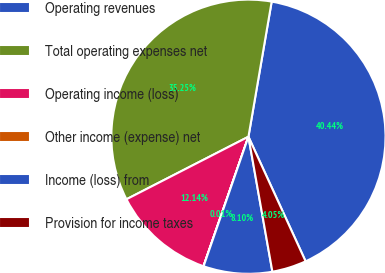<chart> <loc_0><loc_0><loc_500><loc_500><pie_chart><fcel>Operating revenues<fcel>Total operating expenses net<fcel>Operating income (loss)<fcel>Other income (expense) net<fcel>Income (loss) from<fcel>Provision for income taxes<nl><fcel>40.44%<fcel>35.25%<fcel>12.14%<fcel>0.01%<fcel>8.1%<fcel>4.05%<nl></chart> 